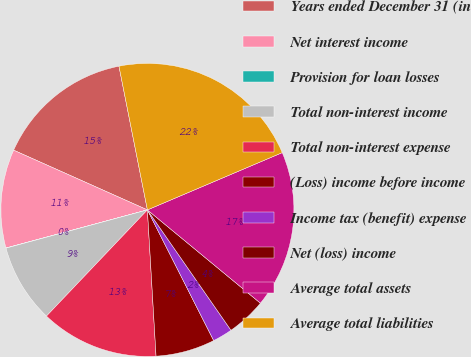<chart> <loc_0><loc_0><loc_500><loc_500><pie_chart><fcel>Years ended December 31 (in<fcel>Net interest income<fcel>Provision for loan losses<fcel>Total non-interest income<fcel>Total non-interest expense<fcel>(Loss) income before income<fcel>Income tax (benefit) expense<fcel>Net (loss) income<fcel>Average total assets<fcel>Average total liabilities<nl><fcel>15.21%<fcel>10.87%<fcel>0.02%<fcel>8.7%<fcel>13.04%<fcel>6.53%<fcel>2.19%<fcel>4.36%<fcel>17.38%<fcel>21.72%<nl></chart> 